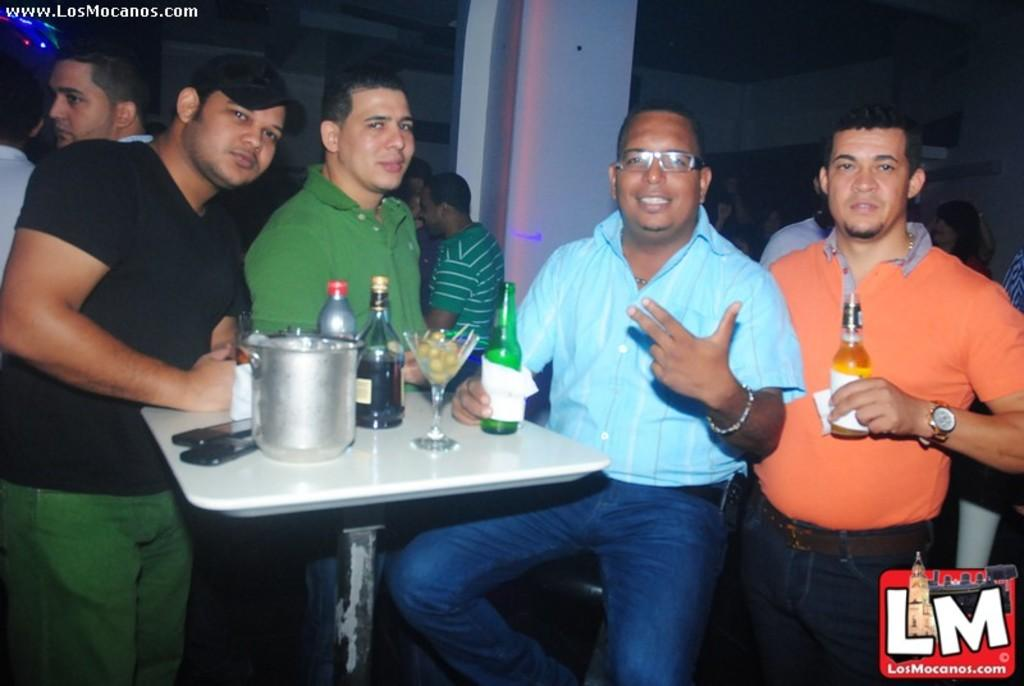Who are the people in the image? There are men in the image. What are the men doing in the image? The men are standing around a table. What is on the table in the image? There are wine bottles on the table. What type of establishment might the image be depicting? The setting appears to be a bar. What message of peace is being conveyed by the wine bottles in the image? There is no message of peace being conveyed by the wine bottles in the image; they are simply objects on a table. 